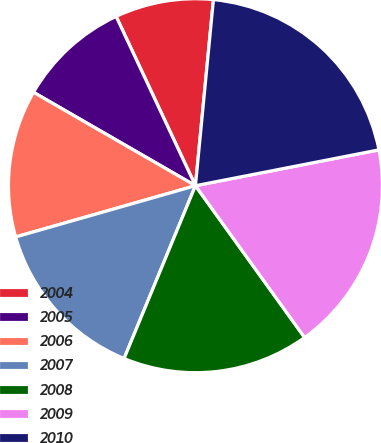<chart> <loc_0><loc_0><loc_500><loc_500><pie_chart><fcel>2004<fcel>2005<fcel>2006<fcel>2007<fcel>2008<fcel>2009<fcel>2010<nl><fcel>8.51%<fcel>9.7%<fcel>12.75%<fcel>14.35%<fcel>16.16%<fcel>18.15%<fcel>20.4%<nl></chart> 